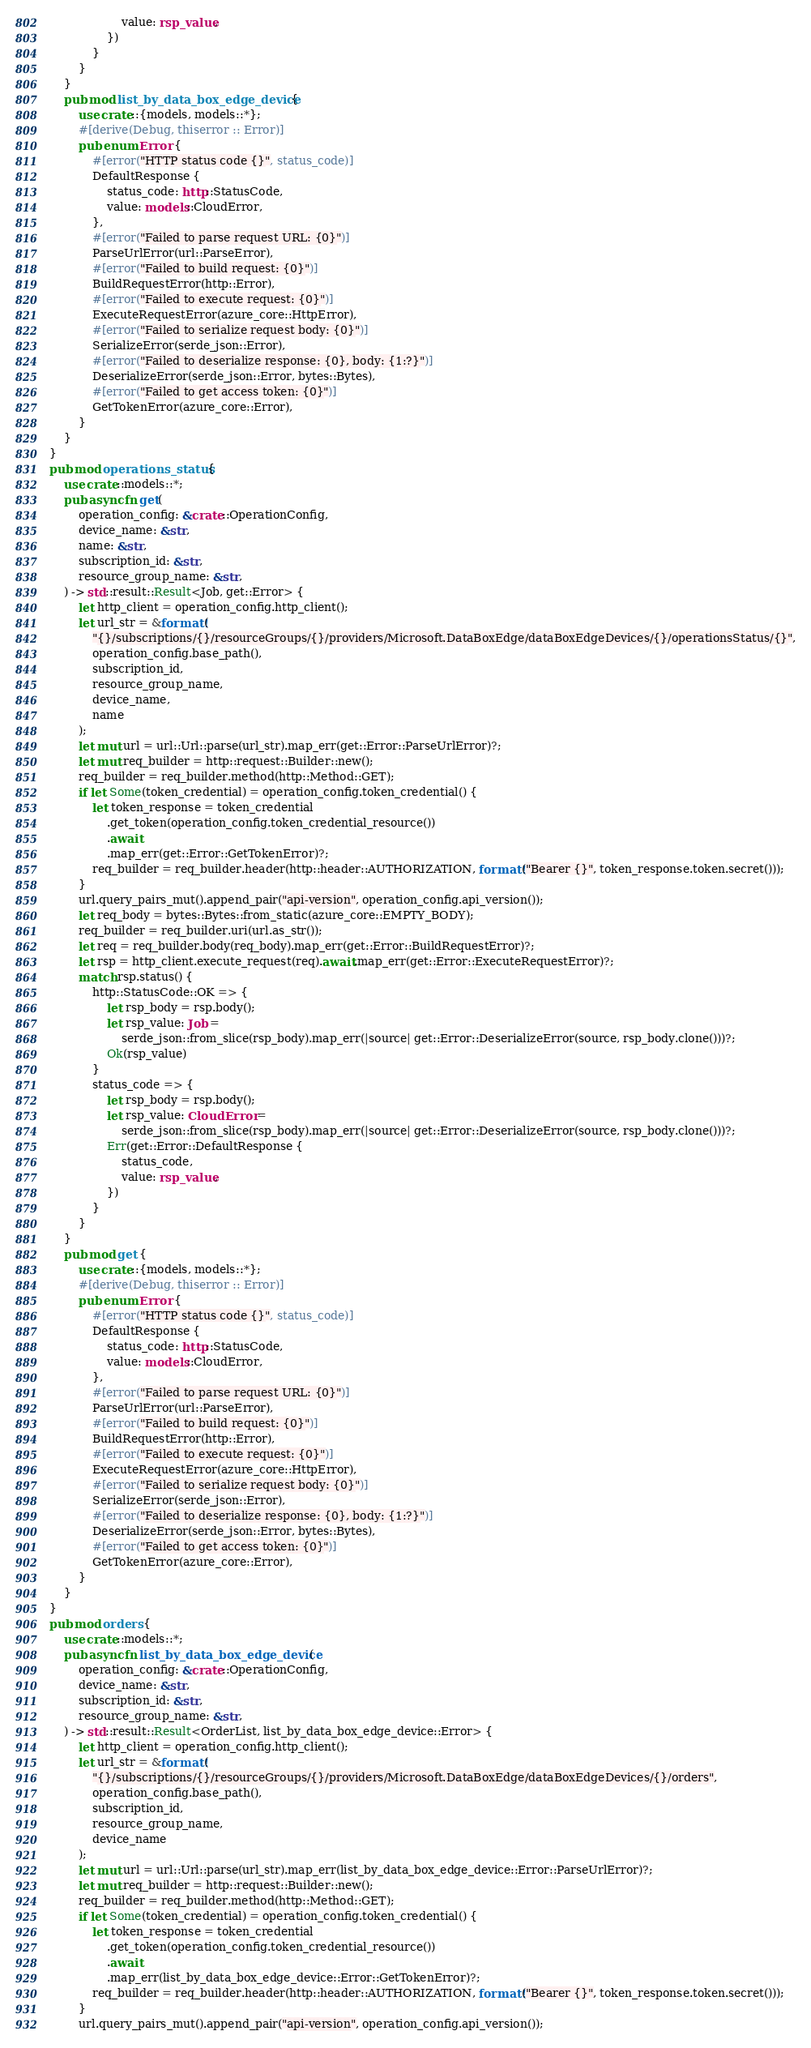Convert code to text. <code><loc_0><loc_0><loc_500><loc_500><_Rust_>                    value: rsp_value,
                })
            }
        }
    }
    pub mod list_by_data_box_edge_device {
        use crate::{models, models::*};
        #[derive(Debug, thiserror :: Error)]
        pub enum Error {
            #[error("HTTP status code {}", status_code)]
            DefaultResponse {
                status_code: http::StatusCode,
                value: models::CloudError,
            },
            #[error("Failed to parse request URL: {0}")]
            ParseUrlError(url::ParseError),
            #[error("Failed to build request: {0}")]
            BuildRequestError(http::Error),
            #[error("Failed to execute request: {0}")]
            ExecuteRequestError(azure_core::HttpError),
            #[error("Failed to serialize request body: {0}")]
            SerializeError(serde_json::Error),
            #[error("Failed to deserialize response: {0}, body: {1:?}")]
            DeserializeError(serde_json::Error, bytes::Bytes),
            #[error("Failed to get access token: {0}")]
            GetTokenError(azure_core::Error),
        }
    }
}
pub mod operations_status {
    use crate::models::*;
    pub async fn get(
        operation_config: &crate::OperationConfig,
        device_name: &str,
        name: &str,
        subscription_id: &str,
        resource_group_name: &str,
    ) -> std::result::Result<Job, get::Error> {
        let http_client = operation_config.http_client();
        let url_str = &format!(
            "{}/subscriptions/{}/resourceGroups/{}/providers/Microsoft.DataBoxEdge/dataBoxEdgeDevices/{}/operationsStatus/{}",
            operation_config.base_path(),
            subscription_id,
            resource_group_name,
            device_name,
            name
        );
        let mut url = url::Url::parse(url_str).map_err(get::Error::ParseUrlError)?;
        let mut req_builder = http::request::Builder::new();
        req_builder = req_builder.method(http::Method::GET);
        if let Some(token_credential) = operation_config.token_credential() {
            let token_response = token_credential
                .get_token(operation_config.token_credential_resource())
                .await
                .map_err(get::Error::GetTokenError)?;
            req_builder = req_builder.header(http::header::AUTHORIZATION, format!("Bearer {}", token_response.token.secret()));
        }
        url.query_pairs_mut().append_pair("api-version", operation_config.api_version());
        let req_body = bytes::Bytes::from_static(azure_core::EMPTY_BODY);
        req_builder = req_builder.uri(url.as_str());
        let req = req_builder.body(req_body).map_err(get::Error::BuildRequestError)?;
        let rsp = http_client.execute_request(req).await.map_err(get::Error::ExecuteRequestError)?;
        match rsp.status() {
            http::StatusCode::OK => {
                let rsp_body = rsp.body();
                let rsp_value: Job =
                    serde_json::from_slice(rsp_body).map_err(|source| get::Error::DeserializeError(source, rsp_body.clone()))?;
                Ok(rsp_value)
            }
            status_code => {
                let rsp_body = rsp.body();
                let rsp_value: CloudError =
                    serde_json::from_slice(rsp_body).map_err(|source| get::Error::DeserializeError(source, rsp_body.clone()))?;
                Err(get::Error::DefaultResponse {
                    status_code,
                    value: rsp_value,
                })
            }
        }
    }
    pub mod get {
        use crate::{models, models::*};
        #[derive(Debug, thiserror :: Error)]
        pub enum Error {
            #[error("HTTP status code {}", status_code)]
            DefaultResponse {
                status_code: http::StatusCode,
                value: models::CloudError,
            },
            #[error("Failed to parse request URL: {0}")]
            ParseUrlError(url::ParseError),
            #[error("Failed to build request: {0}")]
            BuildRequestError(http::Error),
            #[error("Failed to execute request: {0}")]
            ExecuteRequestError(azure_core::HttpError),
            #[error("Failed to serialize request body: {0}")]
            SerializeError(serde_json::Error),
            #[error("Failed to deserialize response: {0}, body: {1:?}")]
            DeserializeError(serde_json::Error, bytes::Bytes),
            #[error("Failed to get access token: {0}")]
            GetTokenError(azure_core::Error),
        }
    }
}
pub mod orders {
    use crate::models::*;
    pub async fn list_by_data_box_edge_device(
        operation_config: &crate::OperationConfig,
        device_name: &str,
        subscription_id: &str,
        resource_group_name: &str,
    ) -> std::result::Result<OrderList, list_by_data_box_edge_device::Error> {
        let http_client = operation_config.http_client();
        let url_str = &format!(
            "{}/subscriptions/{}/resourceGroups/{}/providers/Microsoft.DataBoxEdge/dataBoxEdgeDevices/{}/orders",
            operation_config.base_path(),
            subscription_id,
            resource_group_name,
            device_name
        );
        let mut url = url::Url::parse(url_str).map_err(list_by_data_box_edge_device::Error::ParseUrlError)?;
        let mut req_builder = http::request::Builder::new();
        req_builder = req_builder.method(http::Method::GET);
        if let Some(token_credential) = operation_config.token_credential() {
            let token_response = token_credential
                .get_token(operation_config.token_credential_resource())
                .await
                .map_err(list_by_data_box_edge_device::Error::GetTokenError)?;
            req_builder = req_builder.header(http::header::AUTHORIZATION, format!("Bearer {}", token_response.token.secret()));
        }
        url.query_pairs_mut().append_pair("api-version", operation_config.api_version());</code> 